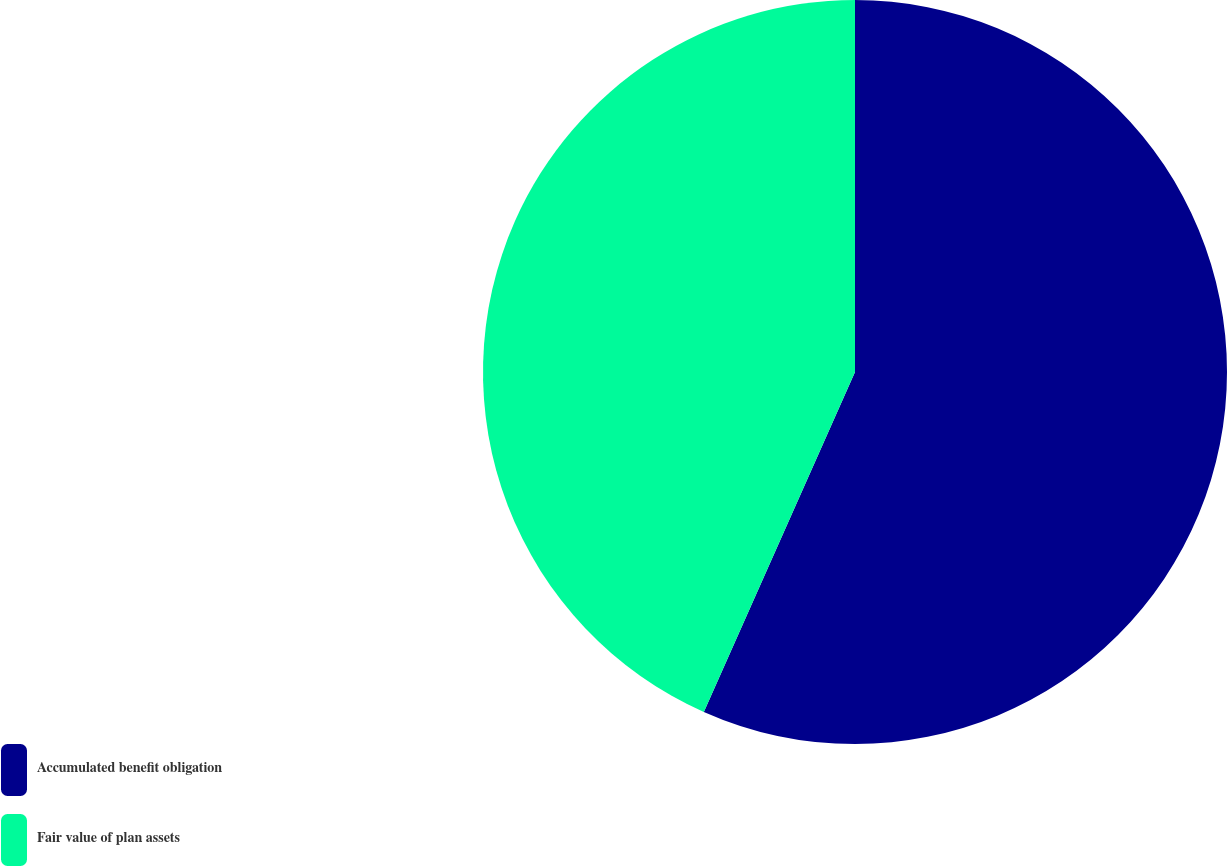Convert chart. <chart><loc_0><loc_0><loc_500><loc_500><pie_chart><fcel>Accumulated benefit obligation<fcel>Fair value of plan assets<nl><fcel>56.66%<fcel>43.34%<nl></chart> 